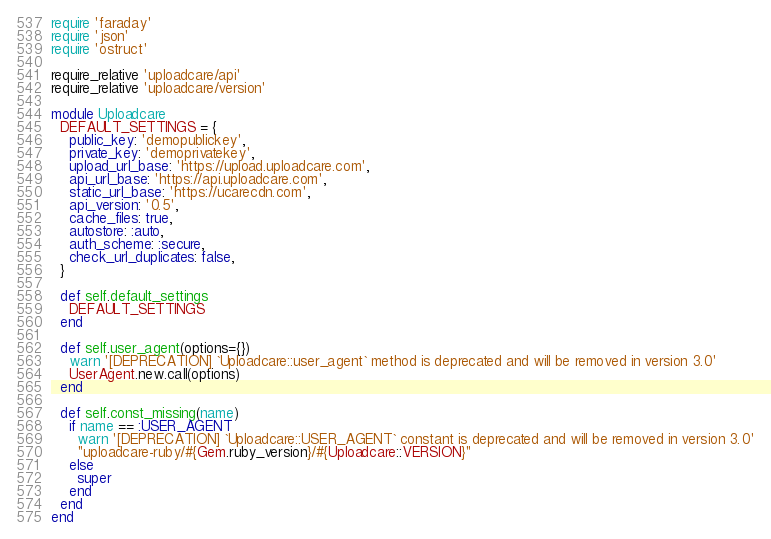Convert code to text. <code><loc_0><loc_0><loc_500><loc_500><_Ruby_>require 'faraday'
require 'json'
require 'ostruct'

require_relative 'uploadcare/api'
require_relative 'uploadcare/version'

module Uploadcare
  DEFAULT_SETTINGS = {
    public_key: 'demopublickey',
    private_key: 'demoprivatekey',
    upload_url_base: 'https://upload.uploadcare.com',
    api_url_base: 'https://api.uploadcare.com',
    static_url_base: 'https://ucarecdn.com',
    api_version: '0.5',
    cache_files: true,
    autostore: :auto,
    auth_scheme: :secure,
    check_url_duplicates: false,
  }

  def self.default_settings
    DEFAULT_SETTINGS
  end

  def self.user_agent(options={})
    warn '[DEPRECATION] `Uploadcare::user_agent` method is deprecated and will be removed in version 3.0'
    UserAgent.new.call(options)
  end

  def self.const_missing(name)
    if name == :USER_AGENT
      warn '[DEPRECATION] `Uploadcare::USER_AGENT` constant is deprecated and will be removed in version 3.0'
      "uploadcare-ruby/#{Gem.ruby_version}/#{Uploadcare::VERSION}"
    else
      super
    end
  end
end
</code> 